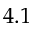Convert formula to latex. <formula><loc_0><loc_0><loc_500><loc_500>4 . 1</formula> 